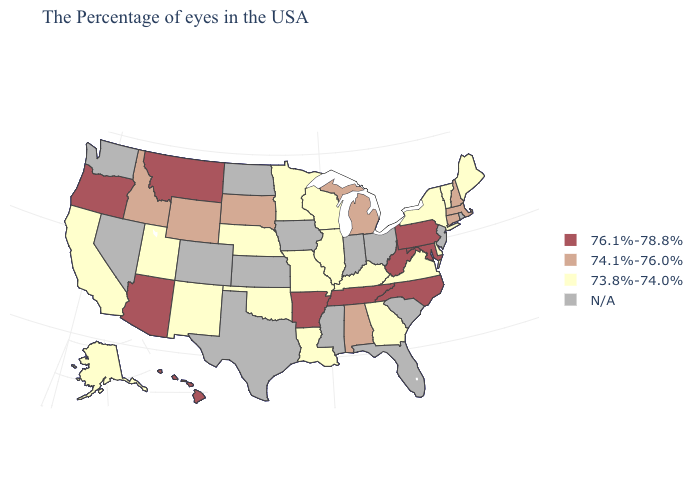Among the states that border Wisconsin , does Illinois have the lowest value?
Answer briefly. Yes. Does South Dakota have the lowest value in the MidWest?
Answer briefly. No. Name the states that have a value in the range 73.8%-74.0%?
Quick response, please. Maine, Vermont, New York, Delaware, Virginia, Georgia, Kentucky, Wisconsin, Illinois, Louisiana, Missouri, Minnesota, Nebraska, Oklahoma, New Mexico, Utah, California, Alaska. Name the states that have a value in the range 74.1%-76.0%?
Short answer required. Massachusetts, New Hampshire, Connecticut, Michigan, Alabama, South Dakota, Wyoming, Idaho. What is the highest value in the MidWest ?
Quick response, please. 74.1%-76.0%. What is the value of Utah?
Quick response, please. 73.8%-74.0%. What is the highest value in states that border Maine?
Short answer required. 74.1%-76.0%. Does South Dakota have the highest value in the MidWest?
Quick response, please. Yes. Does Delaware have the lowest value in the South?
Concise answer only. Yes. Name the states that have a value in the range 74.1%-76.0%?
Short answer required. Massachusetts, New Hampshire, Connecticut, Michigan, Alabama, South Dakota, Wyoming, Idaho. Which states have the lowest value in the West?
Be succinct. New Mexico, Utah, California, Alaska. What is the lowest value in the USA?
Answer briefly. 73.8%-74.0%. What is the value of North Dakota?
Write a very short answer. N/A. What is the highest value in the USA?
Write a very short answer. 76.1%-78.8%. Which states have the lowest value in the South?
Give a very brief answer. Delaware, Virginia, Georgia, Kentucky, Louisiana, Oklahoma. 